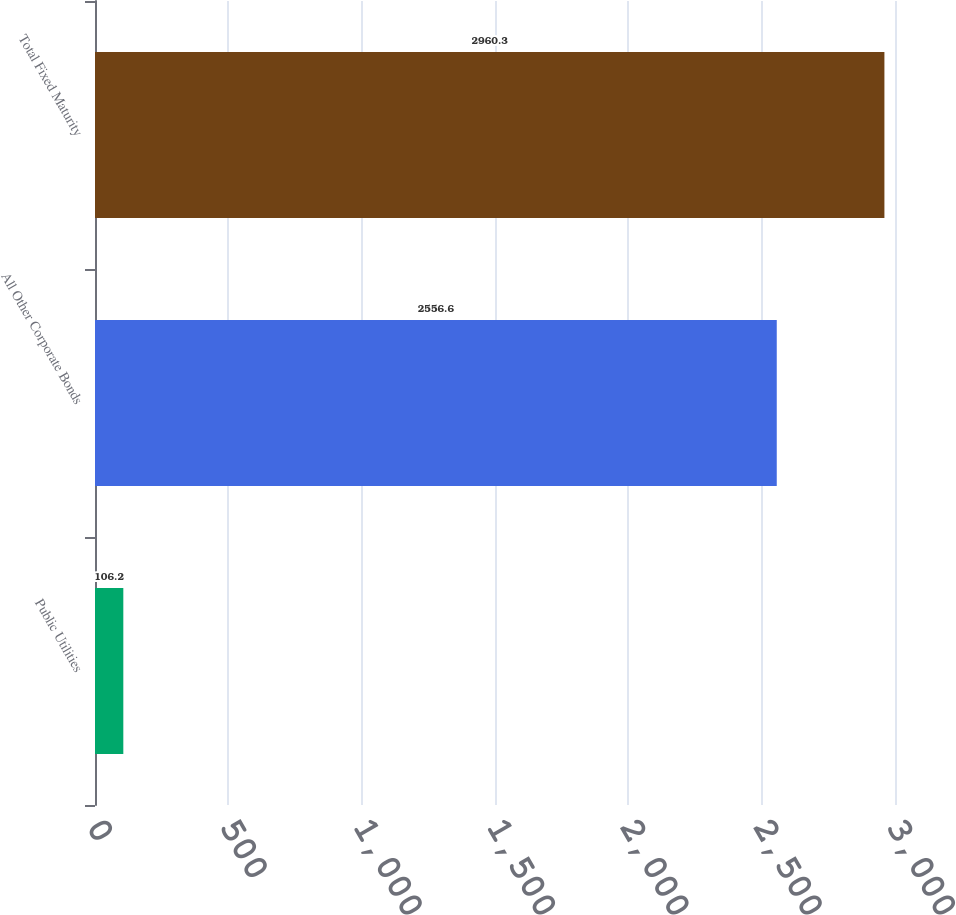Convert chart. <chart><loc_0><loc_0><loc_500><loc_500><bar_chart><fcel>Public Utilities<fcel>All Other Corporate Bonds<fcel>Total Fixed Maturity<nl><fcel>106.2<fcel>2556.6<fcel>2960.3<nl></chart> 